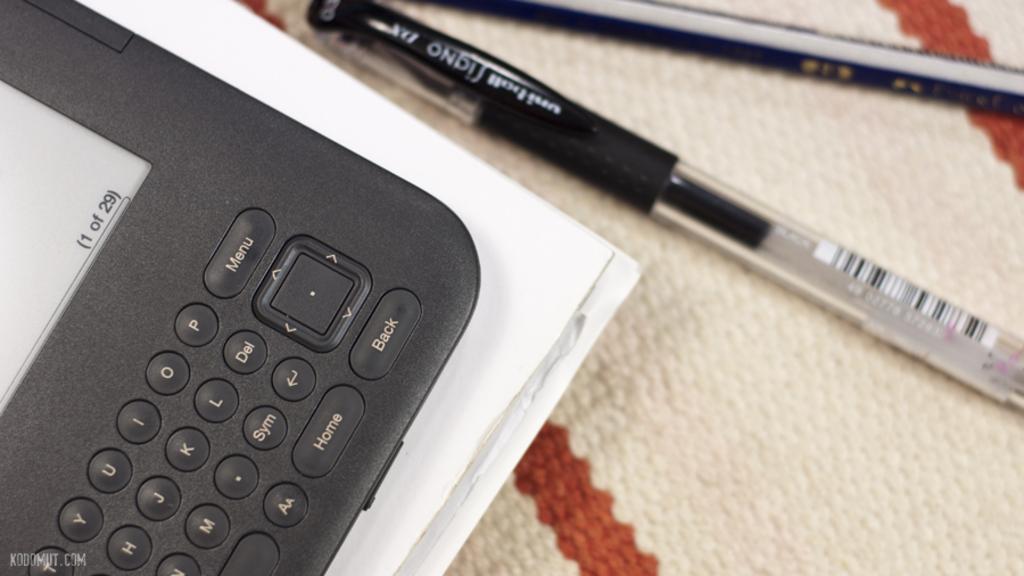What page is the electronic device on?
Offer a terse response. 1. How many pages are there in total?
Your answer should be compact. 29. 